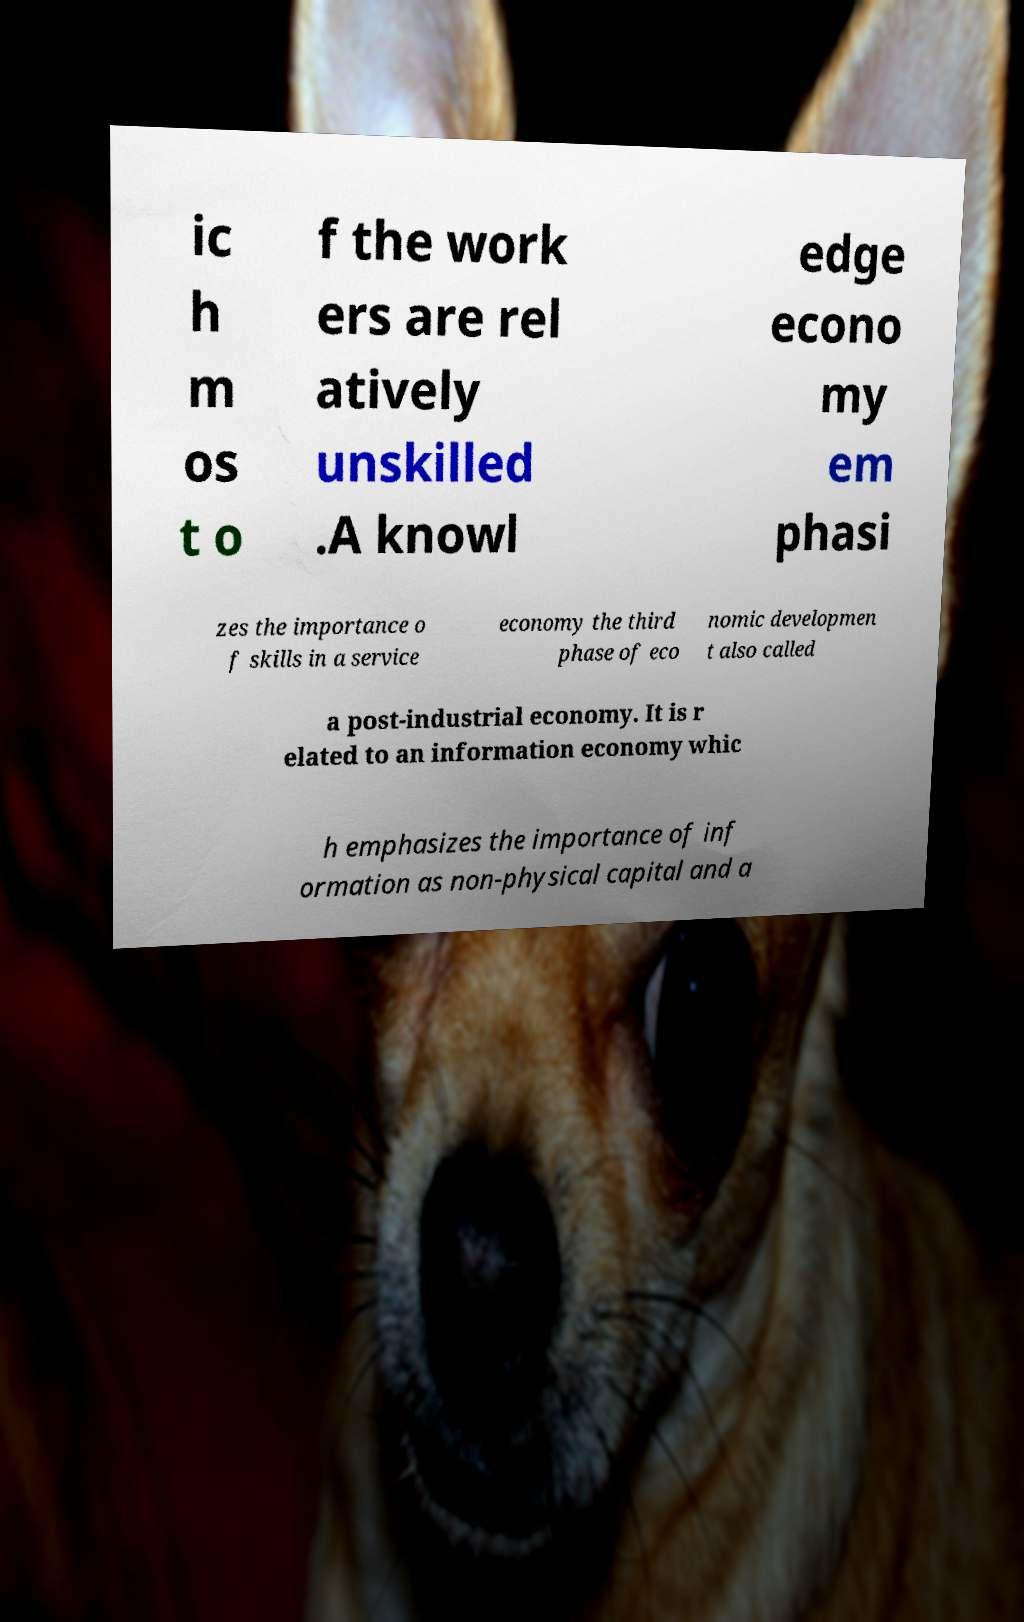Please read and relay the text visible in this image. What does it say? ic h m os t o f the work ers are rel atively unskilled .A knowl edge econo my em phasi zes the importance o f skills in a service economy the third phase of eco nomic developmen t also called a post-industrial economy. It is r elated to an information economy whic h emphasizes the importance of inf ormation as non-physical capital and a 